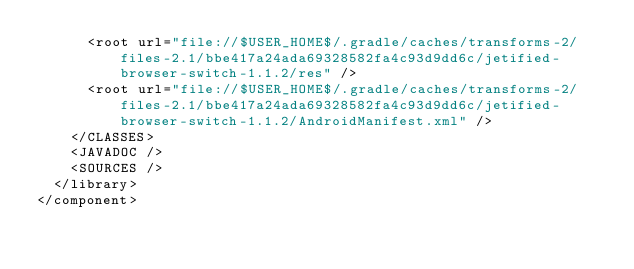Convert code to text. <code><loc_0><loc_0><loc_500><loc_500><_XML_>      <root url="file://$USER_HOME$/.gradle/caches/transforms-2/files-2.1/bbe417a24ada69328582fa4c93d9dd6c/jetified-browser-switch-1.1.2/res" />
      <root url="file://$USER_HOME$/.gradle/caches/transforms-2/files-2.1/bbe417a24ada69328582fa4c93d9dd6c/jetified-browser-switch-1.1.2/AndroidManifest.xml" />
    </CLASSES>
    <JAVADOC />
    <SOURCES />
  </library>
</component></code> 